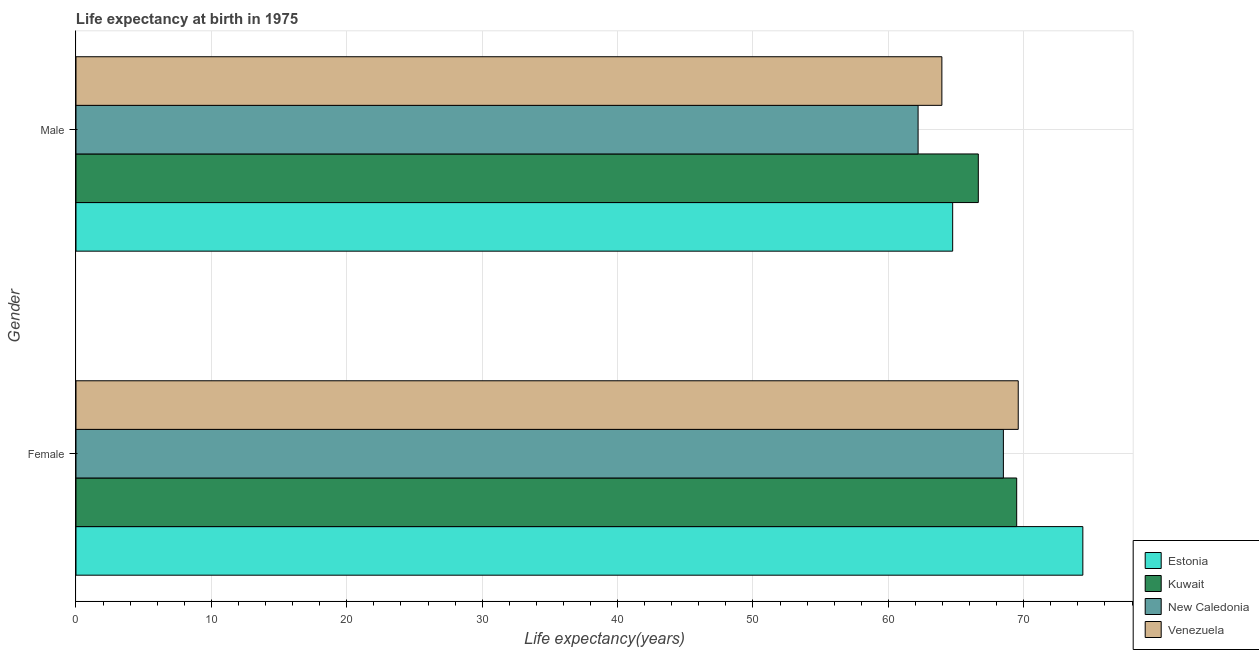How many groups of bars are there?
Provide a short and direct response. 2. How many bars are there on the 2nd tick from the top?
Provide a succinct answer. 4. What is the life expectancy(male) in Kuwait?
Keep it short and to the point. 66.65. Across all countries, what is the maximum life expectancy(male)?
Offer a very short reply. 66.65. Across all countries, what is the minimum life expectancy(female)?
Your response must be concise. 68.5. In which country was the life expectancy(female) maximum?
Offer a terse response. Estonia. In which country was the life expectancy(male) minimum?
Your answer should be compact. New Caledonia. What is the total life expectancy(male) in the graph?
Offer a terse response. 257.56. What is the difference between the life expectancy(male) in Kuwait and that in Estonia?
Provide a succinct answer. 1.89. What is the difference between the life expectancy(male) in Venezuela and the life expectancy(female) in Estonia?
Provide a short and direct response. -10.41. What is the average life expectancy(male) per country?
Your answer should be very brief. 64.39. What is the difference between the life expectancy(female) and life expectancy(male) in Kuwait?
Provide a short and direct response. 2.84. In how many countries, is the life expectancy(male) greater than 62 years?
Offer a very short reply. 4. What is the ratio of the life expectancy(male) in Kuwait to that in New Caledonia?
Make the answer very short. 1.07. Is the life expectancy(female) in Venezuela less than that in New Caledonia?
Your response must be concise. No. What does the 4th bar from the top in Female represents?
Ensure brevity in your answer.  Estonia. What does the 3rd bar from the bottom in Male represents?
Your response must be concise. New Caledonia. Are all the bars in the graph horizontal?
Your answer should be very brief. Yes. How many countries are there in the graph?
Keep it short and to the point. 4. What is the difference between two consecutive major ticks on the X-axis?
Provide a succinct answer. 10. Are the values on the major ticks of X-axis written in scientific E-notation?
Your response must be concise. No. How are the legend labels stacked?
Make the answer very short. Vertical. What is the title of the graph?
Ensure brevity in your answer.  Life expectancy at birth in 1975. Does "Sweden" appear as one of the legend labels in the graph?
Keep it short and to the point. No. What is the label or title of the X-axis?
Your answer should be compact. Life expectancy(years). What is the label or title of the Y-axis?
Ensure brevity in your answer.  Gender. What is the Life expectancy(years) in Estonia in Female?
Provide a succinct answer. 74.37. What is the Life expectancy(years) of Kuwait in Female?
Provide a short and direct response. 69.48. What is the Life expectancy(years) in New Caledonia in Female?
Provide a succinct answer. 68.5. What is the Life expectancy(years) in Venezuela in Female?
Offer a terse response. 69.6. What is the Life expectancy(years) in Estonia in Male?
Give a very brief answer. 64.75. What is the Life expectancy(years) of Kuwait in Male?
Offer a very short reply. 66.65. What is the Life expectancy(years) of New Caledonia in Male?
Keep it short and to the point. 62.2. What is the Life expectancy(years) of Venezuela in Male?
Your answer should be compact. 63.96. Across all Gender, what is the maximum Life expectancy(years) in Estonia?
Offer a very short reply. 74.37. Across all Gender, what is the maximum Life expectancy(years) in Kuwait?
Your answer should be very brief. 69.48. Across all Gender, what is the maximum Life expectancy(years) in New Caledonia?
Keep it short and to the point. 68.5. Across all Gender, what is the maximum Life expectancy(years) of Venezuela?
Give a very brief answer. 69.6. Across all Gender, what is the minimum Life expectancy(years) in Estonia?
Your answer should be compact. 64.75. Across all Gender, what is the minimum Life expectancy(years) in Kuwait?
Your response must be concise. 66.65. Across all Gender, what is the minimum Life expectancy(years) of New Caledonia?
Provide a short and direct response. 62.2. Across all Gender, what is the minimum Life expectancy(years) of Venezuela?
Provide a succinct answer. 63.96. What is the total Life expectancy(years) in Estonia in the graph?
Keep it short and to the point. 139.12. What is the total Life expectancy(years) in Kuwait in the graph?
Your response must be concise. 136.13. What is the total Life expectancy(years) in New Caledonia in the graph?
Keep it short and to the point. 130.7. What is the total Life expectancy(years) in Venezuela in the graph?
Keep it short and to the point. 133.55. What is the difference between the Life expectancy(years) of Estonia in Female and that in Male?
Your response must be concise. 9.61. What is the difference between the Life expectancy(years) in Kuwait in Female and that in Male?
Ensure brevity in your answer.  2.83. What is the difference between the Life expectancy(years) of Venezuela in Female and that in Male?
Provide a short and direct response. 5.64. What is the difference between the Life expectancy(years) of Estonia in Female and the Life expectancy(years) of Kuwait in Male?
Provide a short and direct response. 7.72. What is the difference between the Life expectancy(years) of Estonia in Female and the Life expectancy(years) of New Caledonia in Male?
Your answer should be very brief. 12.17. What is the difference between the Life expectancy(years) of Estonia in Female and the Life expectancy(years) of Venezuela in Male?
Ensure brevity in your answer.  10.41. What is the difference between the Life expectancy(years) in Kuwait in Female and the Life expectancy(years) in New Caledonia in Male?
Your response must be concise. 7.28. What is the difference between the Life expectancy(years) in Kuwait in Female and the Life expectancy(years) in Venezuela in Male?
Provide a succinct answer. 5.53. What is the difference between the Life expectancy(years) of New Caledonia in Female and the Life expectancy(years) of Venezuela in Male?
Provide a short and direct response. 4.54. What is the average Life expectancy(years) in Estonia per Gender?
Give a very brief answer. 69.56. What is the average Life expectancy(years) of Kuwait per Gender?
Keep it short and to the point. 68.06. What is the average Life expectancy(years) in New Caledonia per Gender?
Your answer should be very brief. 65.35. What is the average Life expectancy(years) in Venezuela per Gender?
Give a very brief answer. 66.78. What is the difference between the Life expectancy(years) in Estonia and Life expectancy(years) in Kuwait in Female?
Make the answer very short. 4.89. What is the difference between the Life expectancy(years) of Estonia and Life expectancy(years) of New Caledonia in Female?
Provide a short and direct response. 5.87. What is the difference between the Life expectancy(years) of Estonia and Life expectancy(years) of Venezuela in Female?
Offer a very short reply. 4.77. What is the difference between the Life expectancy(years) in Kuwait and Life expectancy(years) in Venezuela in Female?
Your answer should be very brief. -0.11. What is the difference between the Life expectancy(years) of New Caledonia and Life expectancy(years) of Venezuela in Female?
Your answer should be very brief. -1.1. What is the difference between the Life expectancy(years) in Estonia and Life expectancy(years) in Kuwait in Male?
Provide a succinct answer. -1.89. What is the difference between the Life expectancy(years) in Estonia and Life expectancy(years) in New Caledonia in Male?
Provide a short and direct response. 2.55. What is the difference between the Life expectancy(years) in Estonia and Life expectancy(years) in Venezuela in Male?
Keep it short and to the point. 0.8. What is the difference between the Life expectancy(years) of Kuwait and Life expectancy(years) of New Caledonia in Male?
Provide a short and direct response. 4.45. What is the difference between the Life expectancy(years) of Kuwait and Life expectancy(years) of Venezuela in Male?
Make the answer very short. 2.69. What is the difference between the Life expectancy(years) of New Caledonia and Life expectancy(years) of Venezuela in Male?
Provide a short and direct response. -1.76. What is the ratio of the Life expectancy(years) in Estonia in Female to that in Male?
Keep it short and to the point. 1.15. What is the ratio of the Life expectancy(years) in Kuwait in Female to that in Male?
Give a very brief answer. 1.04. What is the ratio of the Life expectancy(years) in New Caledonia in Female to that in Male?
Your answer should be very brief. 1.1. What is the ratio of the Life expectancy(years) of Venezuela in Female to that in Male?
Your answer should be very brief. 1.09. What is the difference between the highest and the second highest Life expectancy(years) of Estonia?
Make the answer very short. 9.61. What is the difference between the highest and the second highest Life expectancy(years) of Kuwait?
Keep it short and to the point. 2.83. What is the difference between the highest and the second highest Life expectancy(years) of New Caledonia?
Make the answer very short. 6.3. What is the difference between the highest and the second highest Life expectancy(years) in Venezuela?
Offer a very short reply. 5.64. What is the difference between the highest and the lowest Life expectancy(years) in Estonia?
Provide a short and direct response. 9.61. What is the difference between the highest and the lowest Life expectancy(years) of Kuwait?
Offer a very short reply. 2.83. What is the difference between the highest and the lowest Life expectancy(years) of New Caledonia?
Offer a terse response. 6.3. What is the difference between the highest and the lowest Life expectancy(years) in Venezuela?
Your answer should be compact. 5.64. 